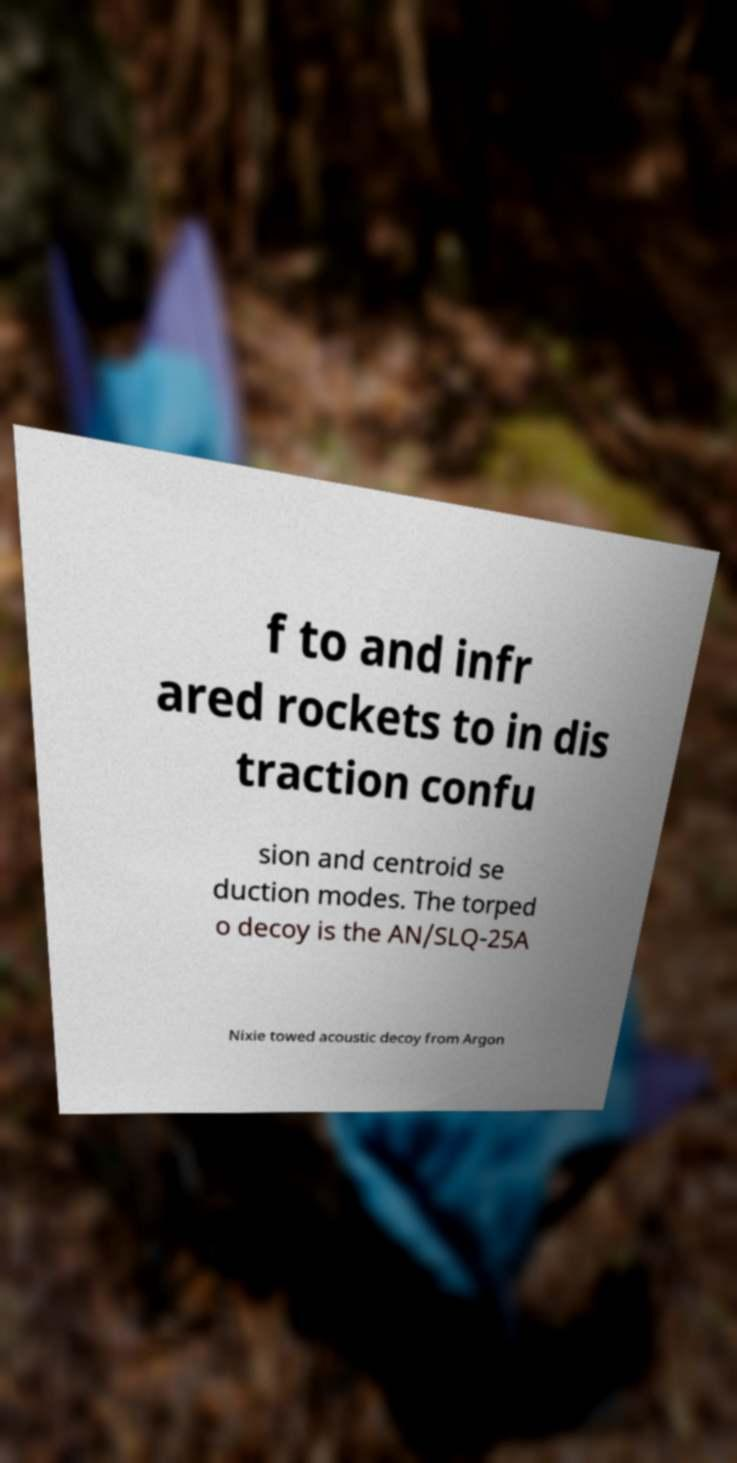Can you read and provide the text displayed in the image?This photo seems to have some interesting text. Can you extract and type it out for me? f to and infr ared rockets to in dis traction confu sion and centroid se duction modes. The torped o decoy is the AN/SLQ-25A Nixie towed acoustic decoy from Argon 